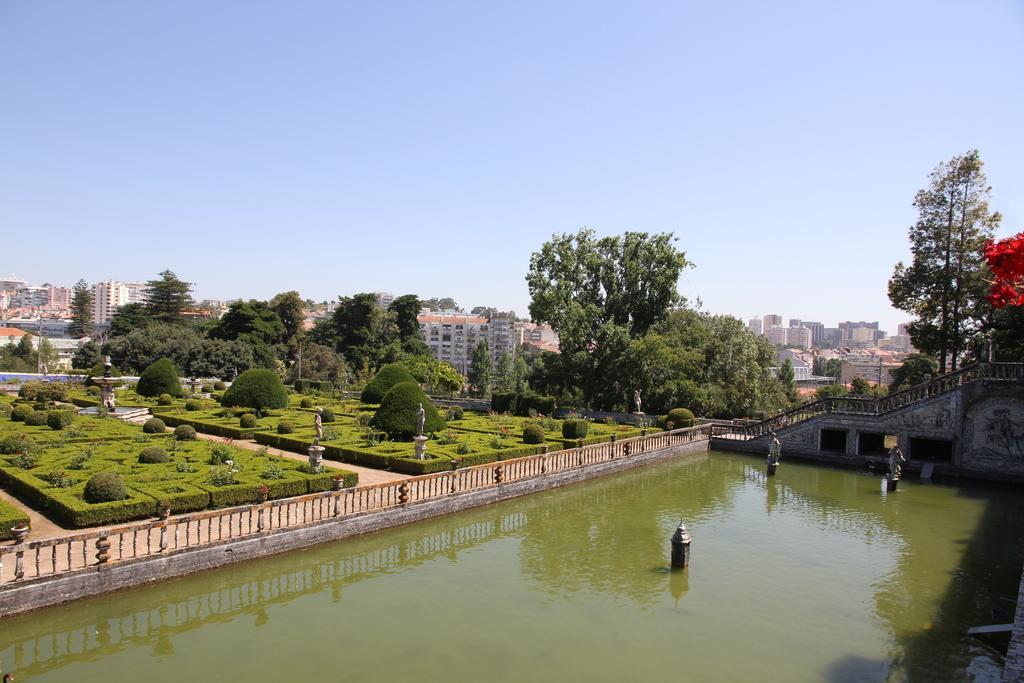How would you summarize this image in a sentence or two? In this image we can see a few buildings, there are some trees, plants, water, fence and the statues, in the background, we can see the sky. 